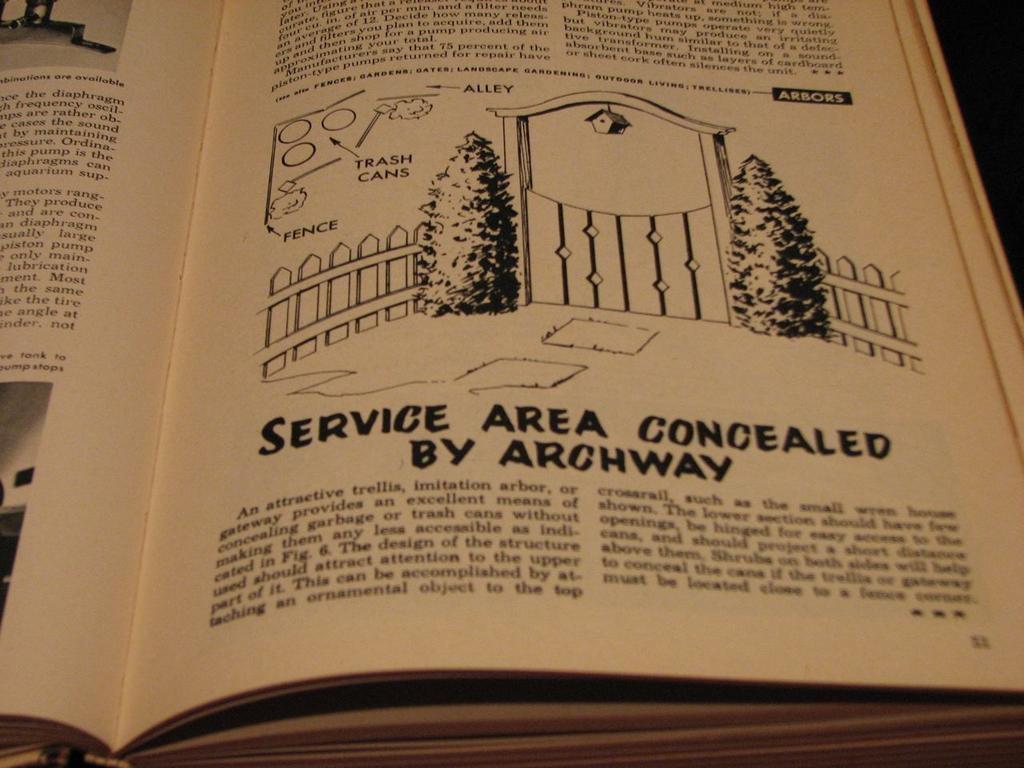What is the main subject of the image? The main subject of the image is a book. What type of drawing can be found in the center of the picture? There is a drawing of trees in the center of the picture. What other drawings are present in the image? There is a drawing of fencing and a drawing of a gate in the picture. Is there any text in the image? Yes, there is text in the picture. What type of jewel is depicted in the drawing of the gate? There is no jewel depicted in the drawing of the gate; it is a drawing of a gate without any jewels. 